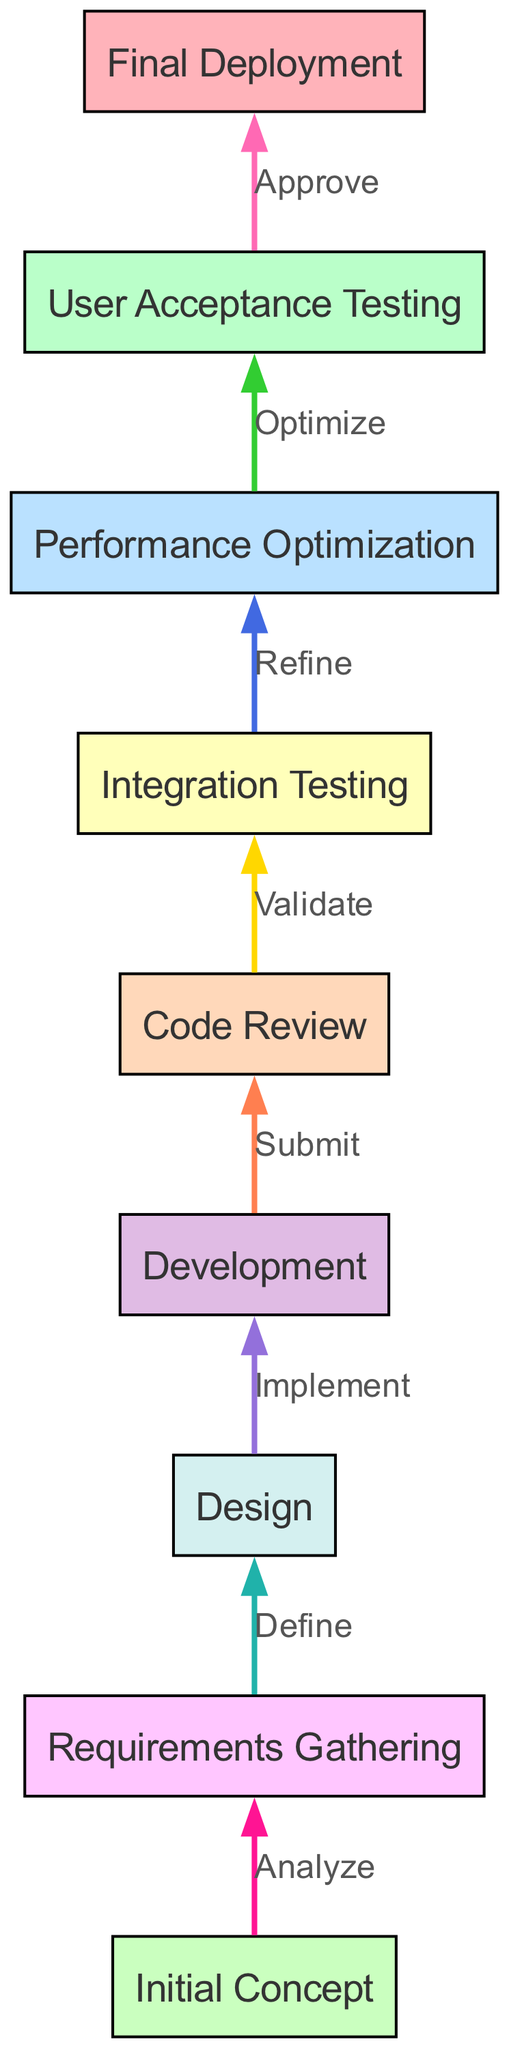What is the starting point of the project development lifecycle? The diagram indicates that the starting point is "Initial Concept," which is the first node in the flow.
Answer: Initial Concept How many nodes are present in the diagram? By counting all nodes listed in the data, there are a total of nine nodes representing various stages in the lifecycle.
Answer: Nine What is the terminal point of the project development lifecycle? The last node in the diagram flow indicates the terminal point is "Final Deployment," which represents the end of the lifecycle.
Answer: Final Deployment What action leads from "Performance Optimization" to "User Acceptance Testing"? The edge between "Performance Optimization" and "User Acceptance Testing" is labeled "Optimize," indicating that the optimization process leads directly to this testing phase.
Answer: Optimize Which node follows "Development" in the flow? According to the diagram, "Code Review" is the immediate successor to "Development," meaning it comes next in the process.
Answer: Code Review What is the relationship between "Requirements Gathering" and "Design"? The edge labeled "Define" connects these two nodes, indicating that "Requirements Gathering" defines the "Design" phase.
Answer: Define What is the fourth node in the flow order? By examining the flow from the bottom up, the fourth node is "Integration Testing," which follows three other stages before it.
Answer: Integration Testing Which node has the most incoming edges? Analyzing the edges, the node "User Acceptance Testing" has the most incoming edges, specifically one from "Performance Optimization," which reflects the final stage of development verification.
Answer: User Acceptance Testing What happens after the "Code Review" phase? Following the "Code Review" phase, the workflow leads to "Integration Testing," indicating a sequential flow from review to integration.
Answer: Integration Testing 